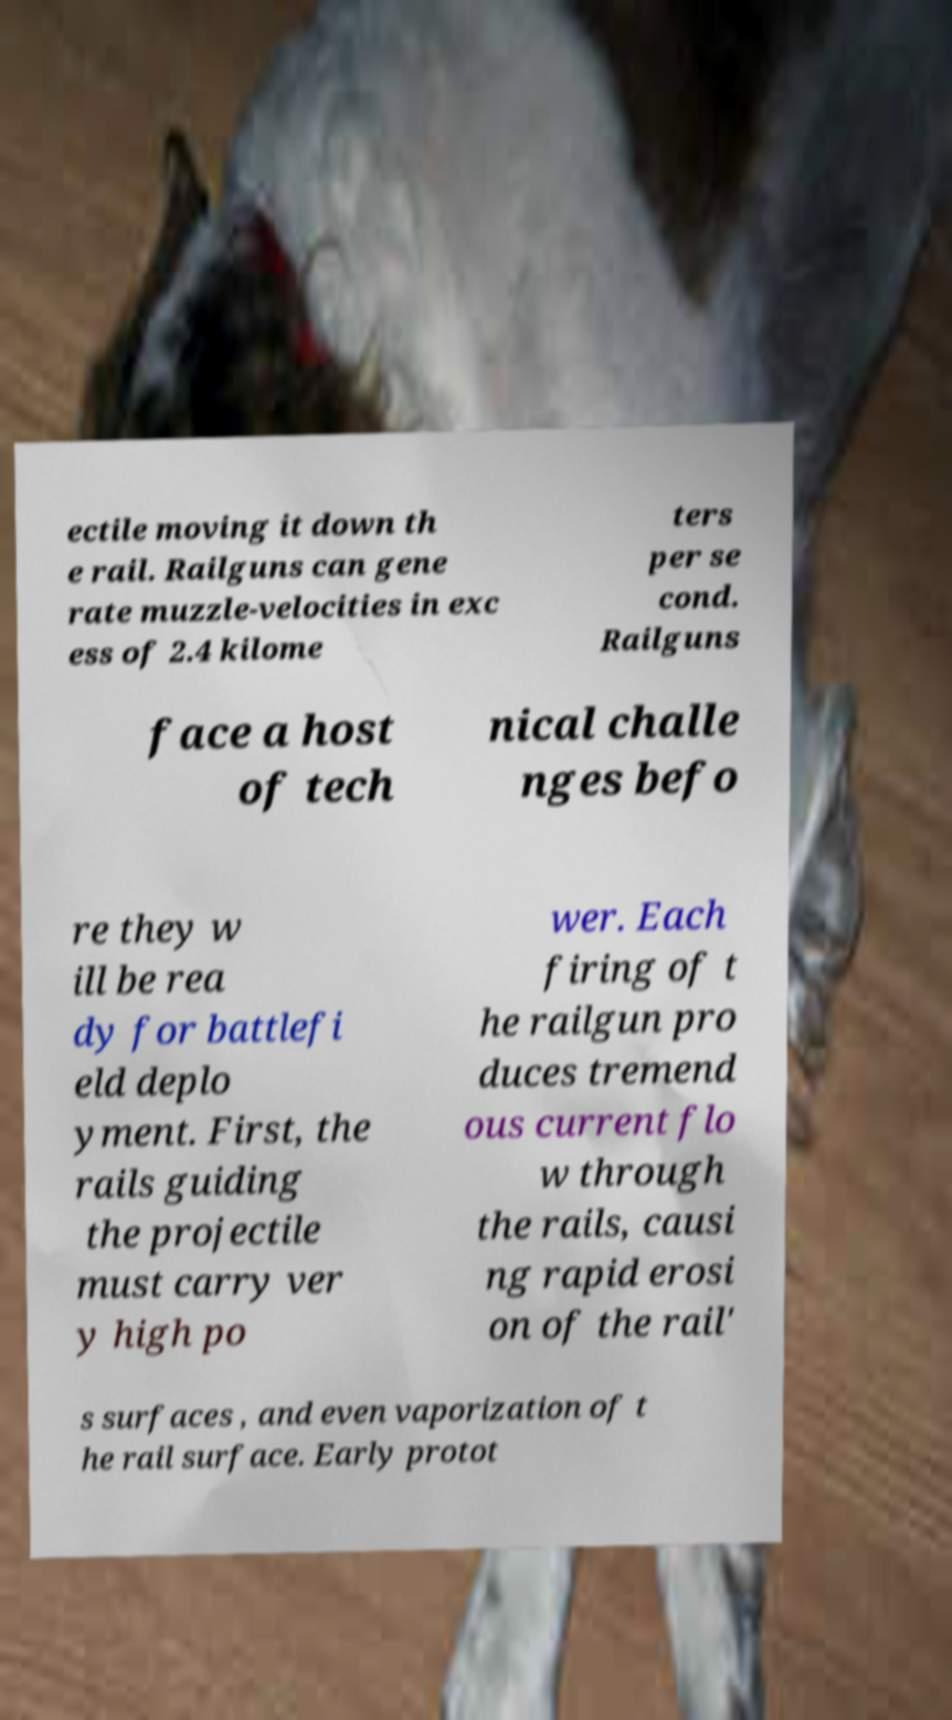For documentation purposes, I need the text within this image transcribed. Could you provide that? ectile moving it down th e rail. Railguns can gene rate muzzle-velocities in exc ess of 2.4 kilome ters per se cond. Railguns face a host of tech nical challe nges befo re they w ill be rea dy for battlefi eld deplo yment. First, the rails guiding the projectile must carry ver y high po wer. Each firing of t he railgun pro duces tremend ous current flo w through the rails, causi ng rapid erosi on of the rail' s surfaces , and even vaporization of t he rail surface. Early protot 